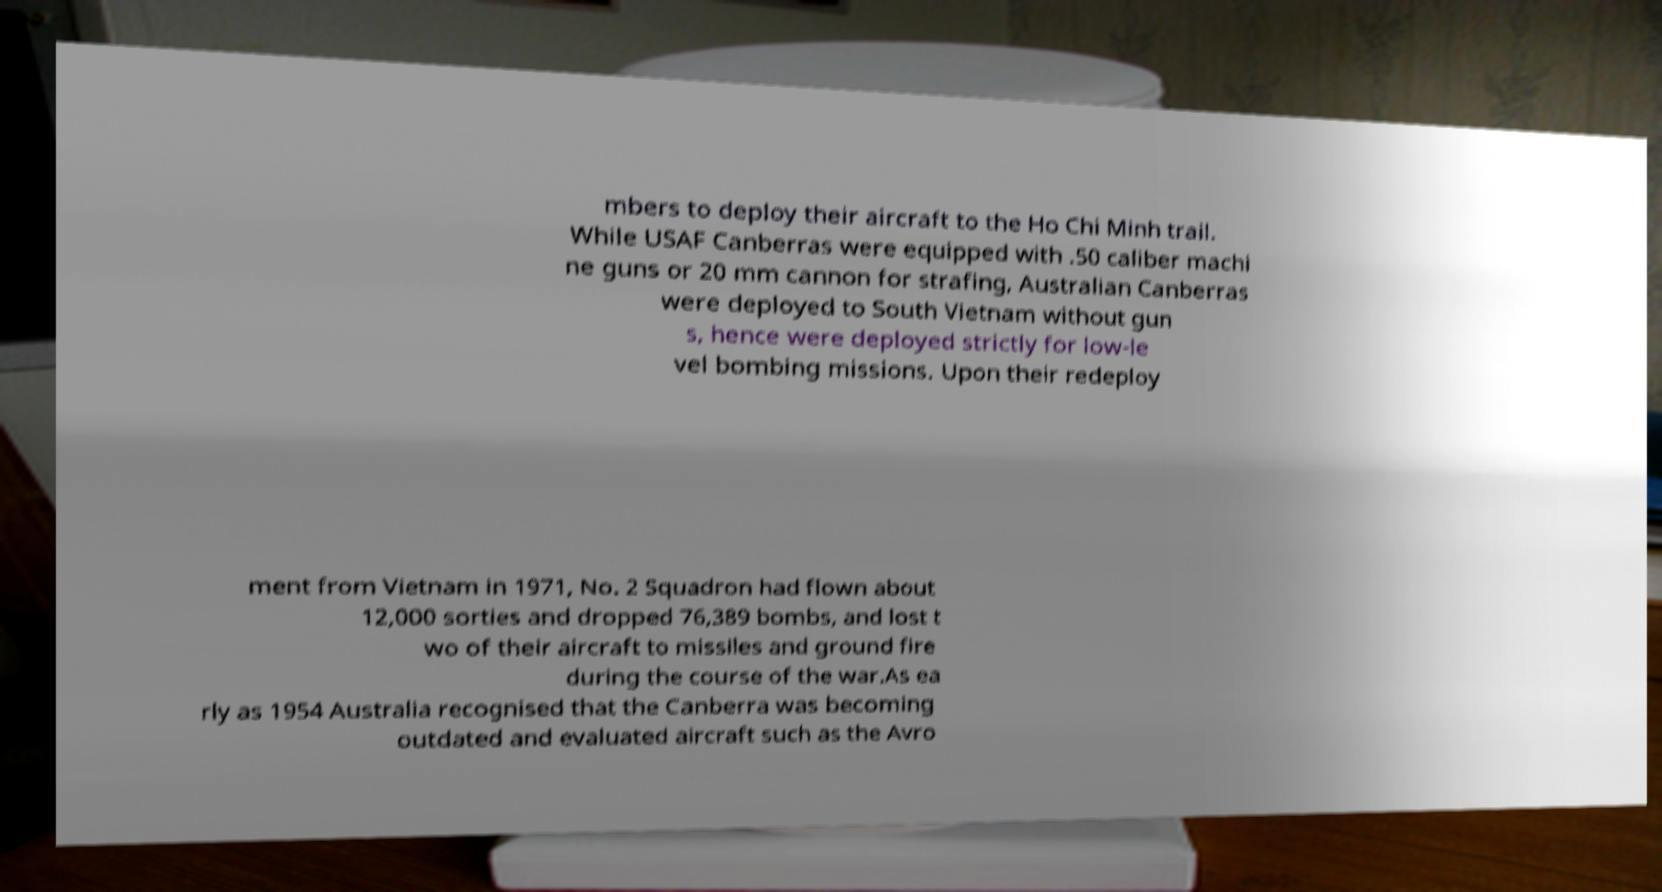What messages or text are displayed in this image? I need them in a readable, typed format. mbers to deploy their aircraft to the Ho Chi Minh trail. While USAF Canberras were equipped with .50 caliber machi ne guns or 20 mm cannon for strafing, Australian Canberras were deployed to South Vietnam without gun s, hence were deployed strictly for low-le vel bombing missions. Upon their redeploy ment from Vietnam in 1971, No. 2 Squadron had flown about 12,000 sorties and dropped 76,389 bombs, and lost t wo of their aircraft to missiles and ground fire during the course of the war.As ea rly as 1954 Australia recognised that the Canberra was becoming outdated and evaluated aircraft such as the Avro 